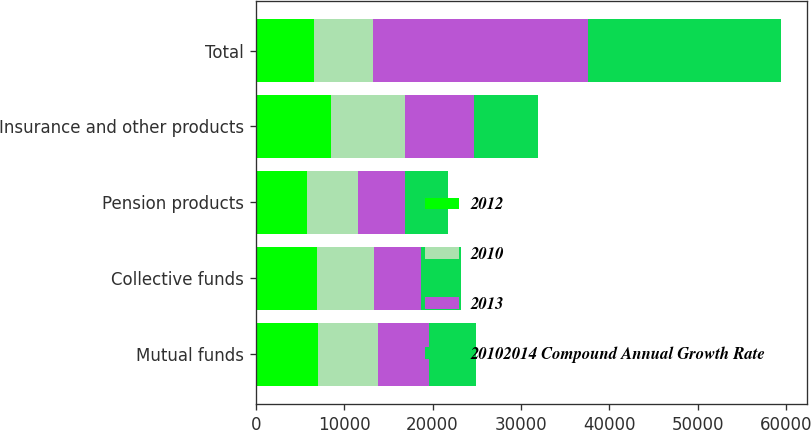Convert chart to OTSL. <chart><loc_0><loc_0><loc_500><loc_500><stacked_bar_chart><ecel><fcel>Mutual funds<fcel>Collective funds<fcel>Pension products<fcel>Insurance and other products<fcel>Total<nl><fcel>2012<fcel>6992<fcel>6949<fcel>5746<fcel>8501<fcel>6619.5<nl><fcel>2010<fcel>6811<fcel>6428<fcel>5851<fcel>8337<fcel>6619.5<nl><fcel>2013<fcel>5852<fcel>5363<fcel>5339<fcel>7817<fcel>24371<nl><fcel>20102014 Compound Annual Growth Rate<fcel>5265<fcel>4437<fcel>4837<fcel>7268<fcel>21807<nl></chart> 